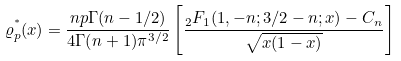<formula> <loc_0><loc_0><loc_500><loc_500>\varrho _ { p } ^ { ^ { * } } ( x ) = \frac { n p \Gamma ( n - 1 / 2 ) } { 4 \Gamma ( n + 1 ) \pi ^ { 3 / 2 } } \left [ \frac { _ { 2 } F _ { 1 } ( 1 , - n ; 3 / 2 - n ; x ) - C _ { n } } { \sqrt { x ( 1 - x ) } } \right ]</formula> 